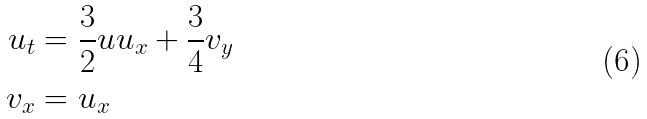Convert formula to latex. <formula><loc_0><loc_0><loc_500><loc_500>u _ { t } & = \frac { 3 } { 2 } u u _ { x } + \frac { 3 } { 4 } v _ { y } \\ v _ { x } & = u _ { x }</formula> 